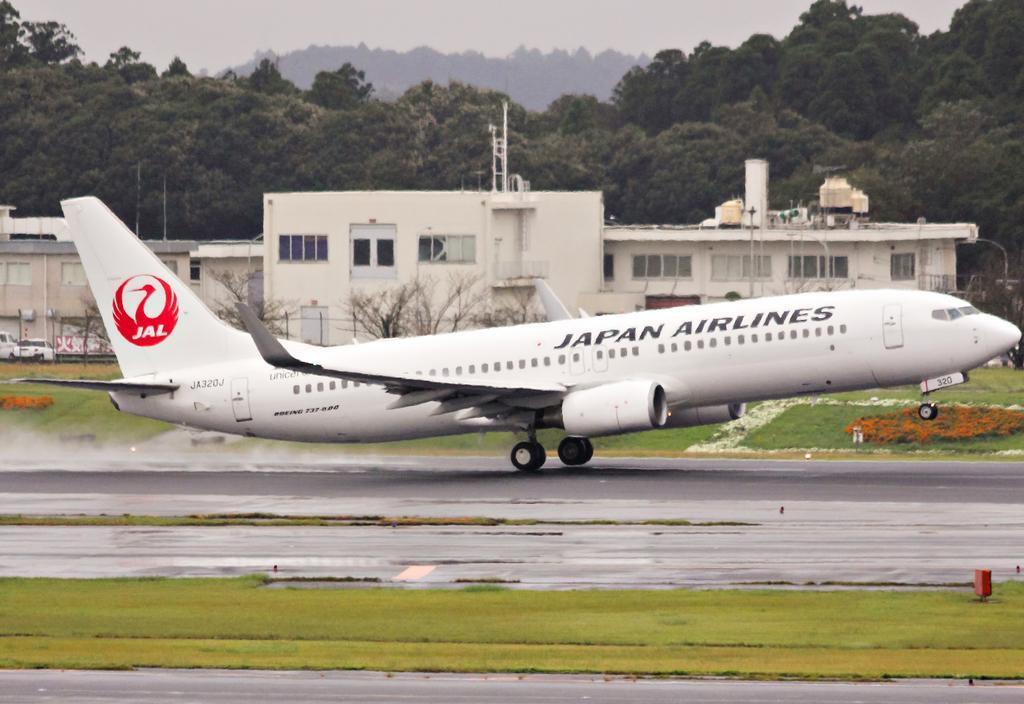Can you describe this image briefly? In this image we can see an aeroplane on the runway. We can also see some grass, plants with flowers, buildings with windows, poles, a group of trees, the hills and the sky which looks cloudy. 